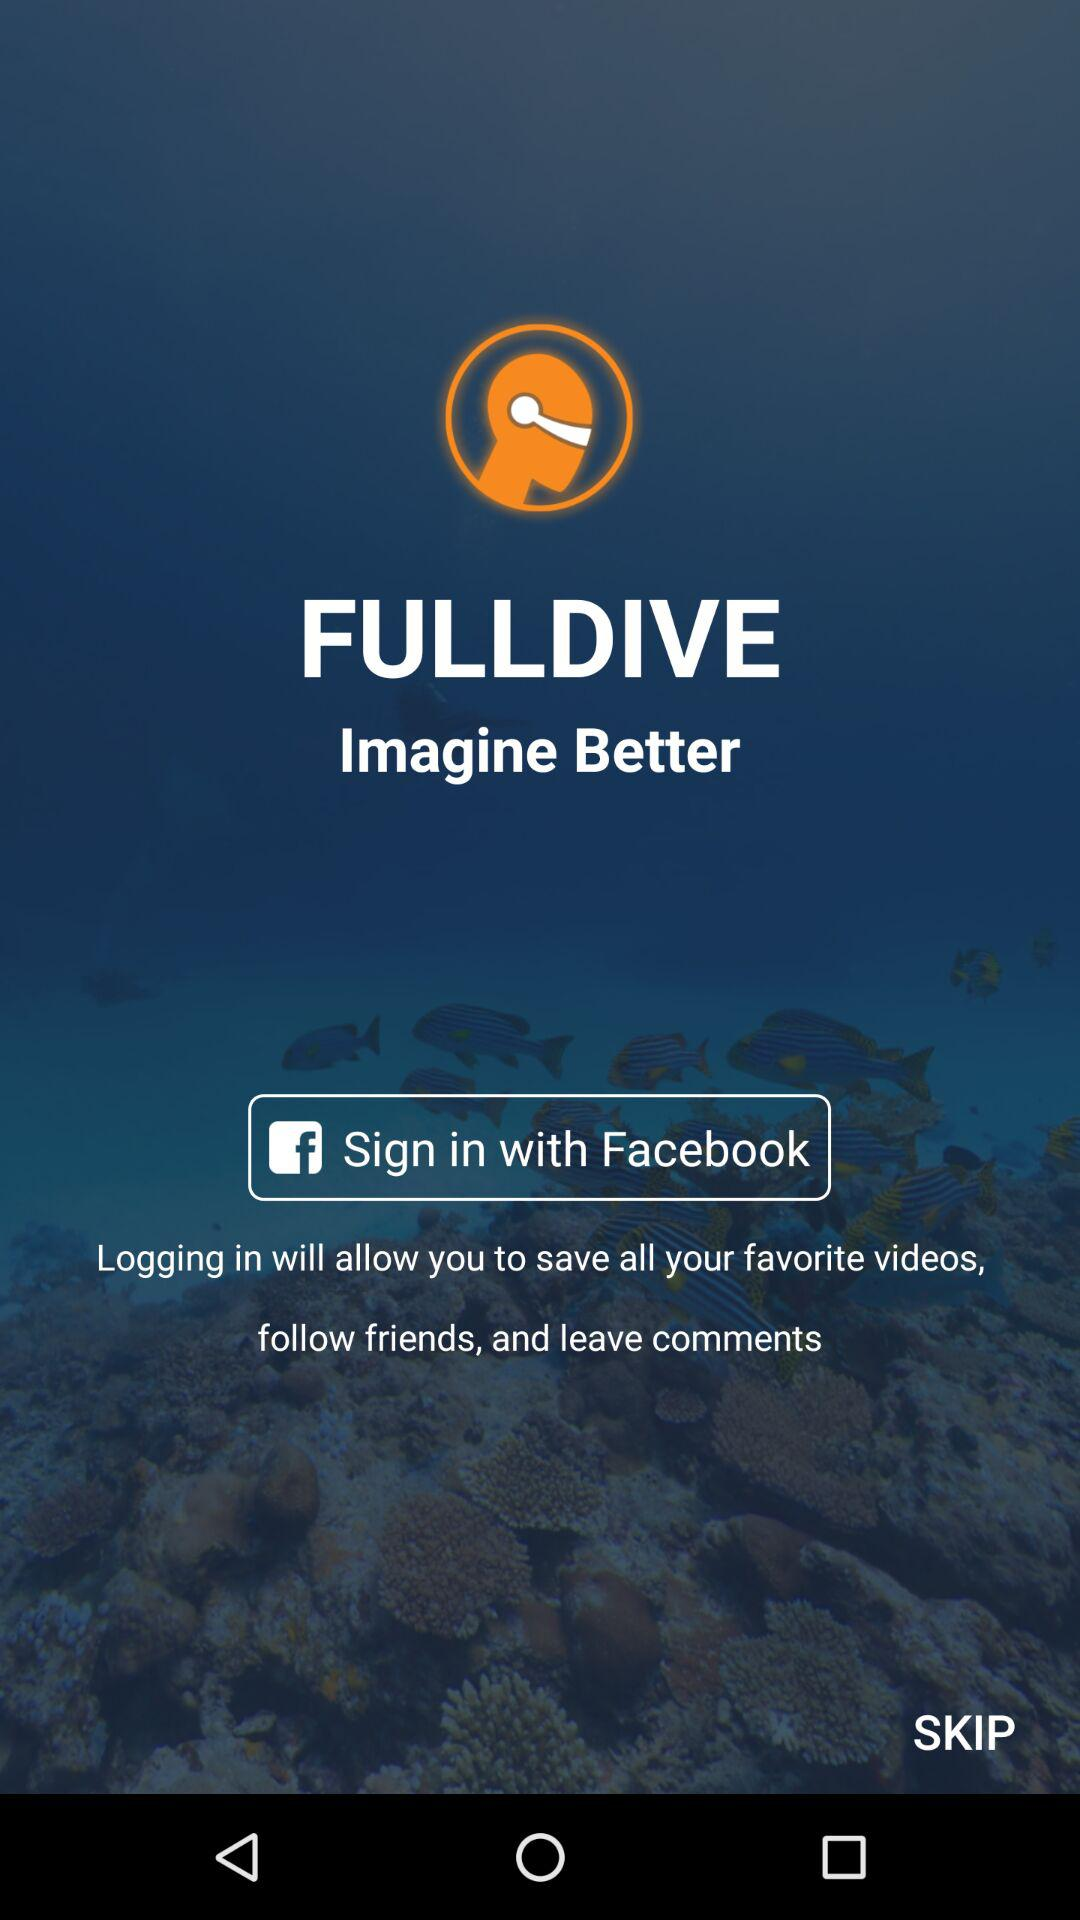What is the name of the application? The name of the application is "Fulldive". 